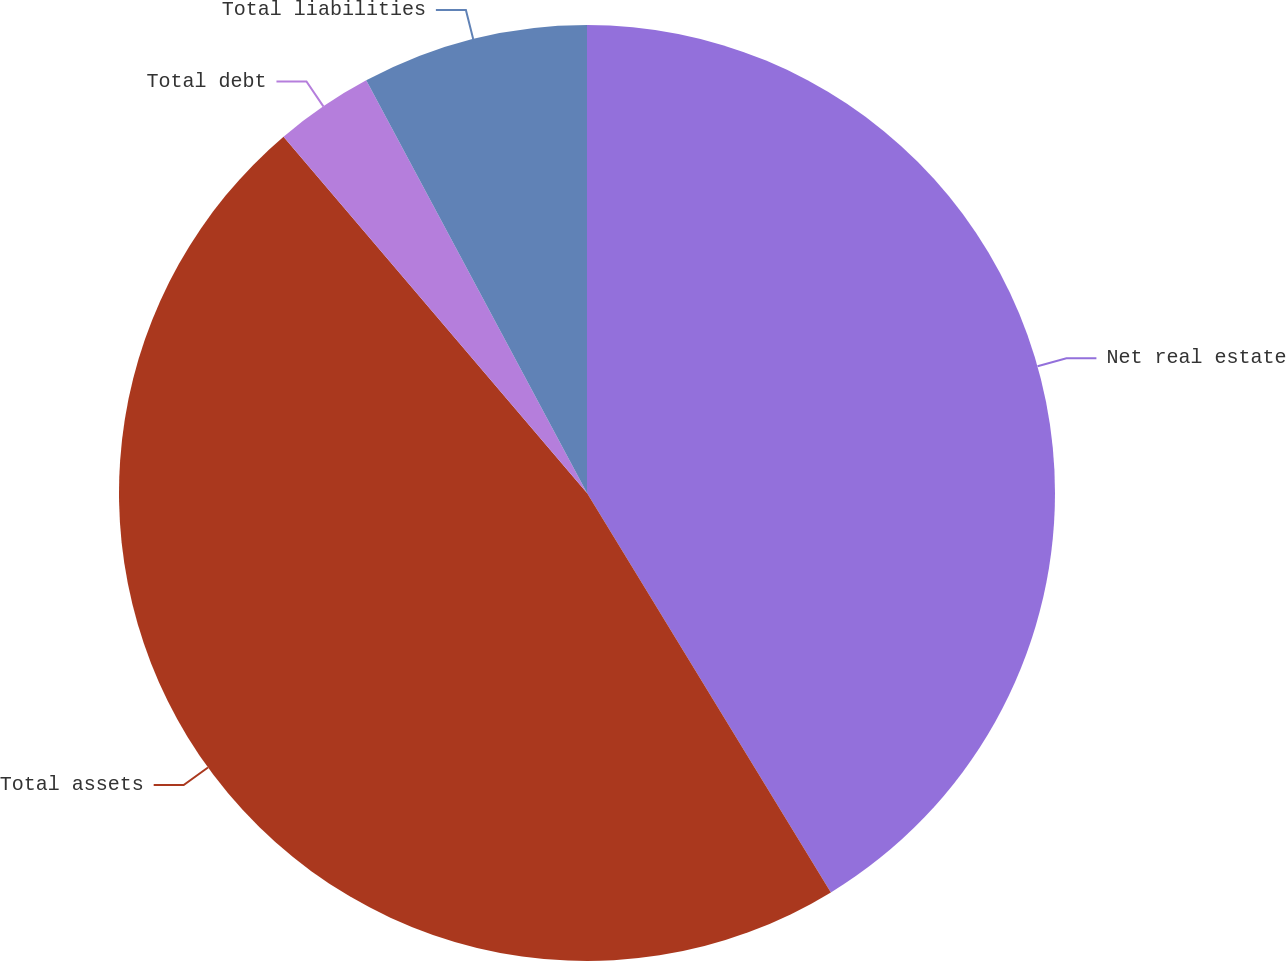Convert chart. <chart><loc_0><loc_0><loc_500><loc_500><pie_chart><fcel>Net real estate<fcel>Total assets<fcel>Total debt<fcel>Total liabilities<nl><fcel>41.28%<fcel>47.5%<fcel>3.41%<fcel>7.82%<nl></chart> 